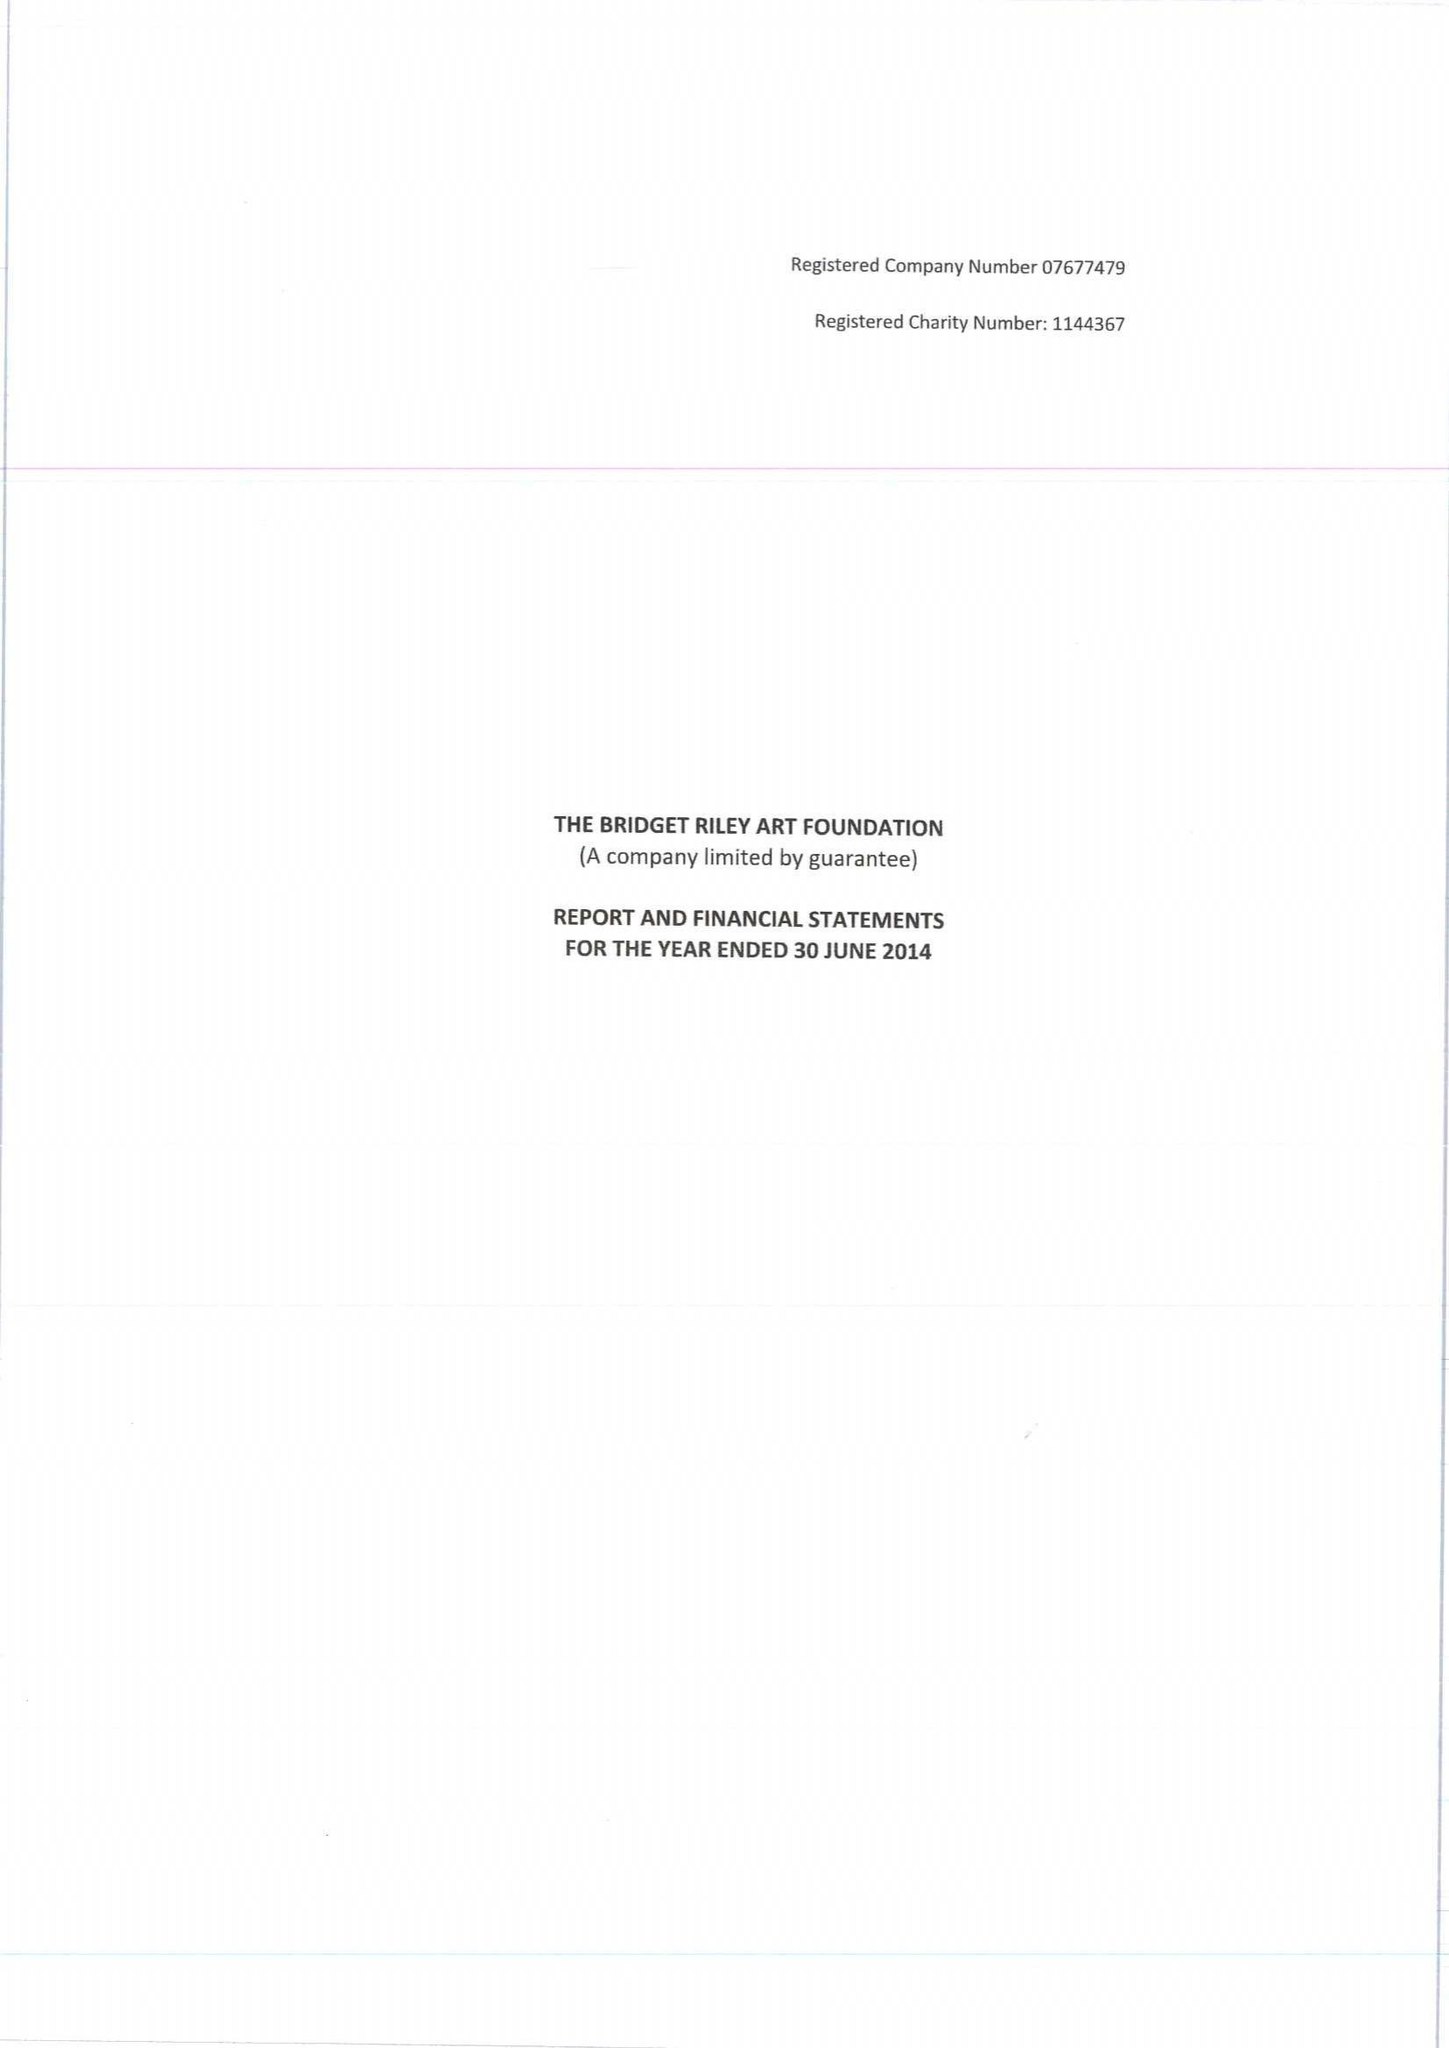What is the value for the spending_annually_in_british_pounds?
Answer the question using a single word or phrase. 87566.00 